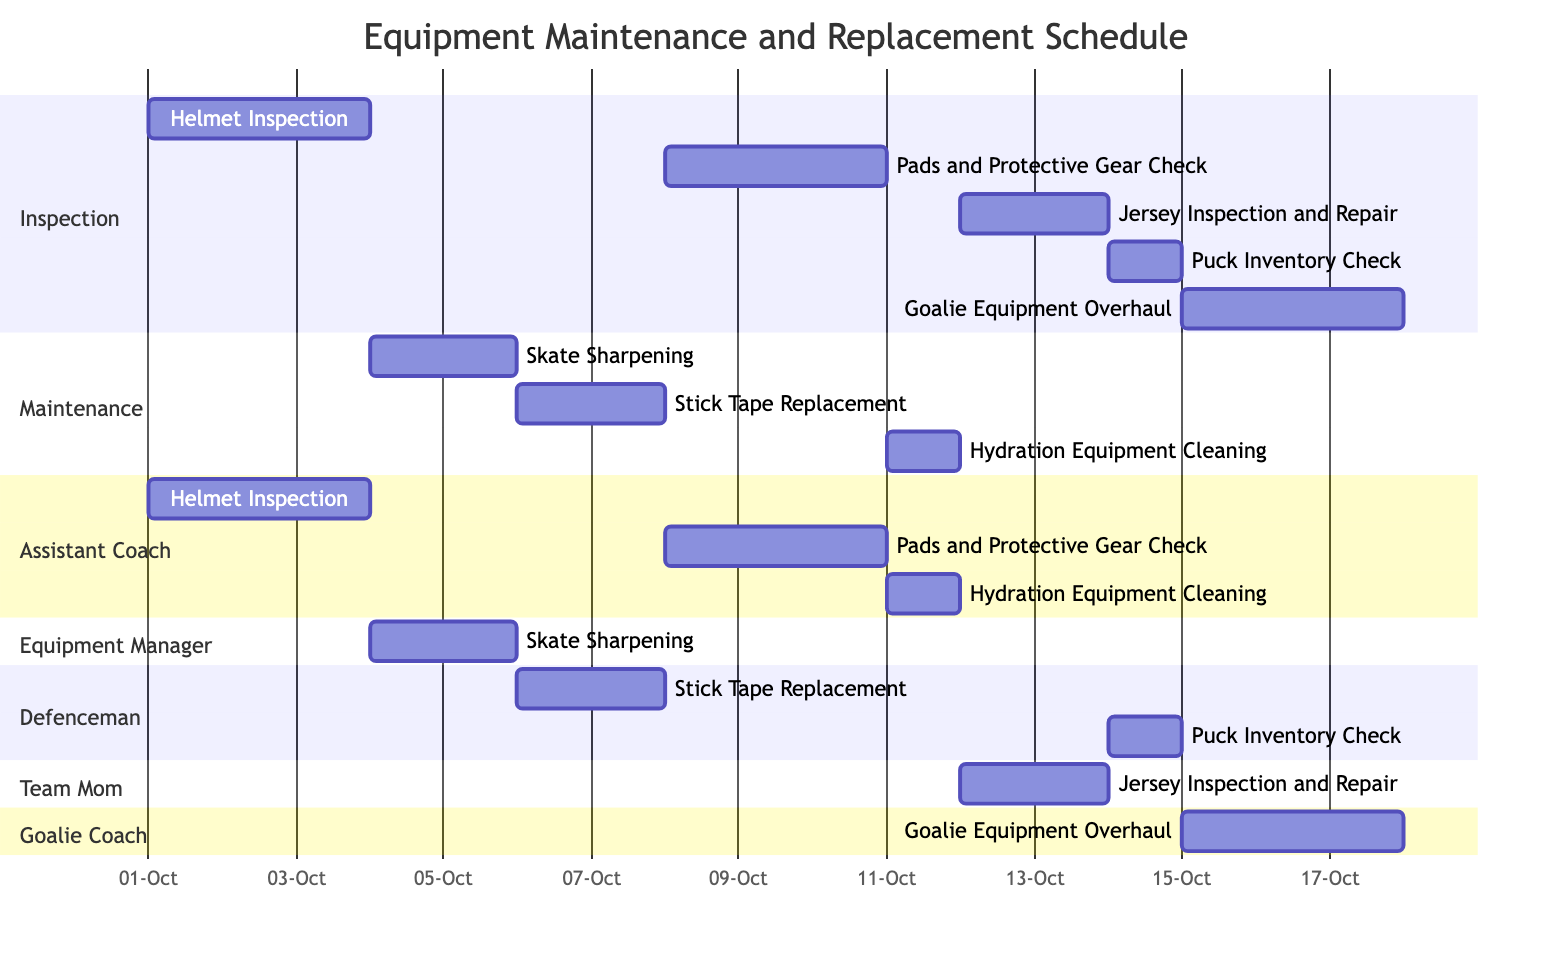What is the duration of the Helmet Inspection task? The Gantt Chart shows that the Helmet Inspection starts on October 1, 2023, and ends on October 3, 2023. By calculating the days from start to end, we find that it spans for 3 days.
Answer: 3 days Who is responsible for the Skate Sharpening? The Swim Chart lists the Skate Sharpening task under the section "Equipment Manager". This indicates that the Equipment Manager is responsible for this task.
Answer: Equipment Manager Which task is scheduled on October 11, 2023? By examining the timeline in the Gantt Chart, the Hydration Equipment Cleaning task is listed as occurring on October 11, 2023, indicating it is a one-day task on that date.
Answer: Hydration Equipment Cleaning How many tasks are assigned to Defenceman? The Gantt Chart lists two tasks under the section for Defenceman: Stick Tape Replacement and Puck Inventory Check, indicating there are a total of 2 tasks assigned.
Answer: 2 tasks What is the relationship between the tasks "Stick Tape Replacement" and "Puck Inventory Check"? Both tasks are assigned to the Defenceman and are scheduled to occur on different days. Stick Tape Replacement occurs from October 6 to 7, while Puck Inventory Check is on October 14, indicating they are sequential but separate tasks assigned to the same person.
Answer: Sequential but separate Which task requires the Team Mom's attention? The Jersey Inspection and Repair task is assigned to the Team Mom, as indicated under that section in the Gantt Chart. This is the only task specifically associated with her.
Answer: Jersey Inspection and Repair When does the Goalie Equipment Overhaul end? The Gantt Chart displays the Goalie Equipment Overhaul starting on October 15, 2023, and running for 3 days until October 17, 2023. Thus, the end date can be directly noted from the chart.
Answer: October 17, 2023 What is the main purpose of the Puck Inventory Check task? The details for the Puck Inventory Check task explain that its purpose is to count and inspect all pucks, discard damaged ones, and order new pucks if necessary. This task primarily focuses on maintaining puck quality for games.
Answer: Count and inspect all pucks What section contains the task scheduled for October 6, 2023? The task scheduled for October 6, 2023, is Stick Tape Replacement. It appears in the Maintenance section of the Gantt Chart. Thus, we can determine the task's main category by looking at the section headers.
Answer: Maintenance section 